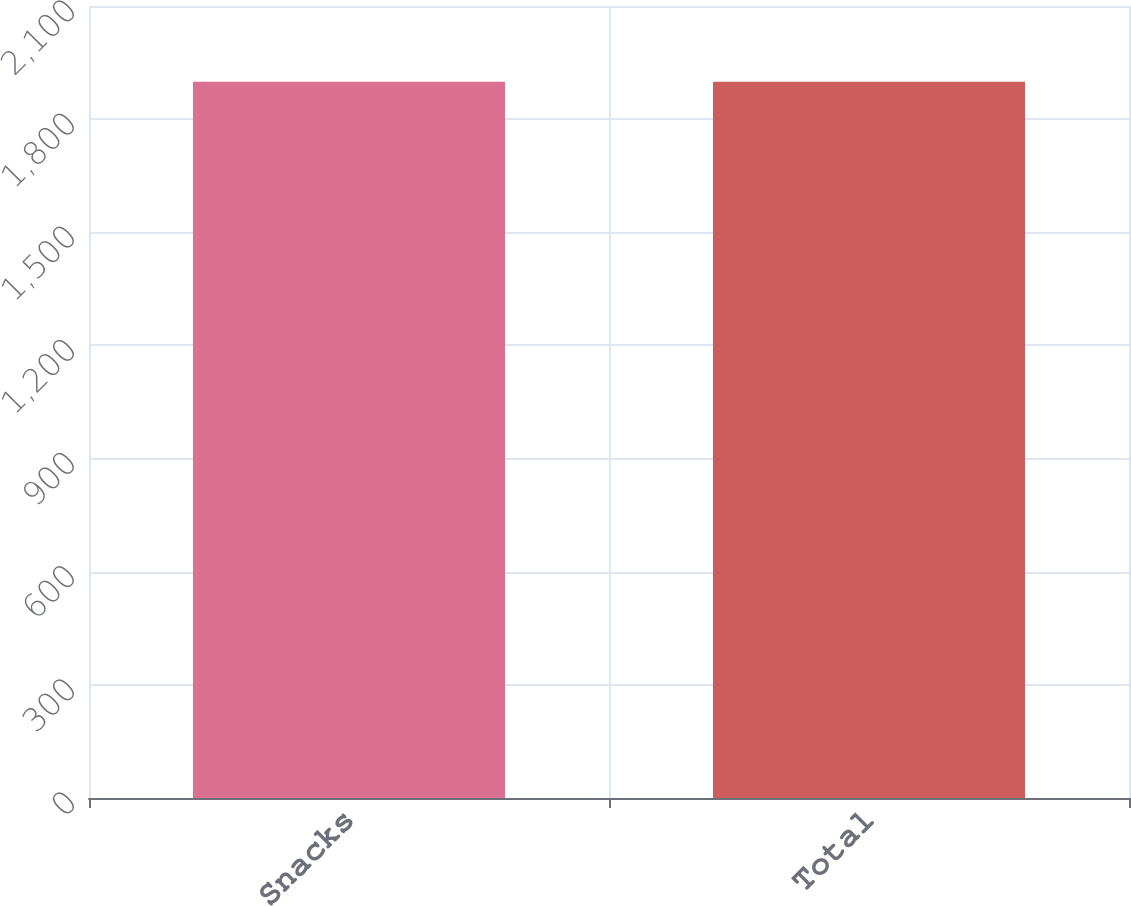<chart> <loc_0><loc_0><loc_500><loc_500><bar_chart><fcel>Snacks<fcel>Total<nl><fcel>1899<fcel>1899.1<nl></chart> 